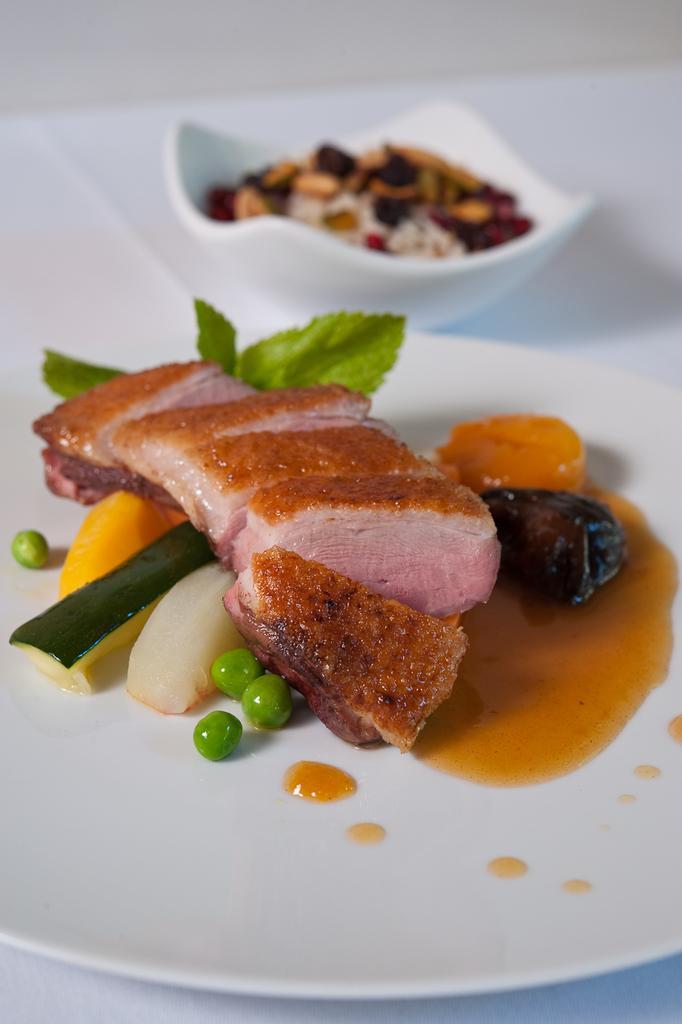How would you summarize this image in a sentence or two? In this picture I can see food items on the plate and in a bowl, on the object. 